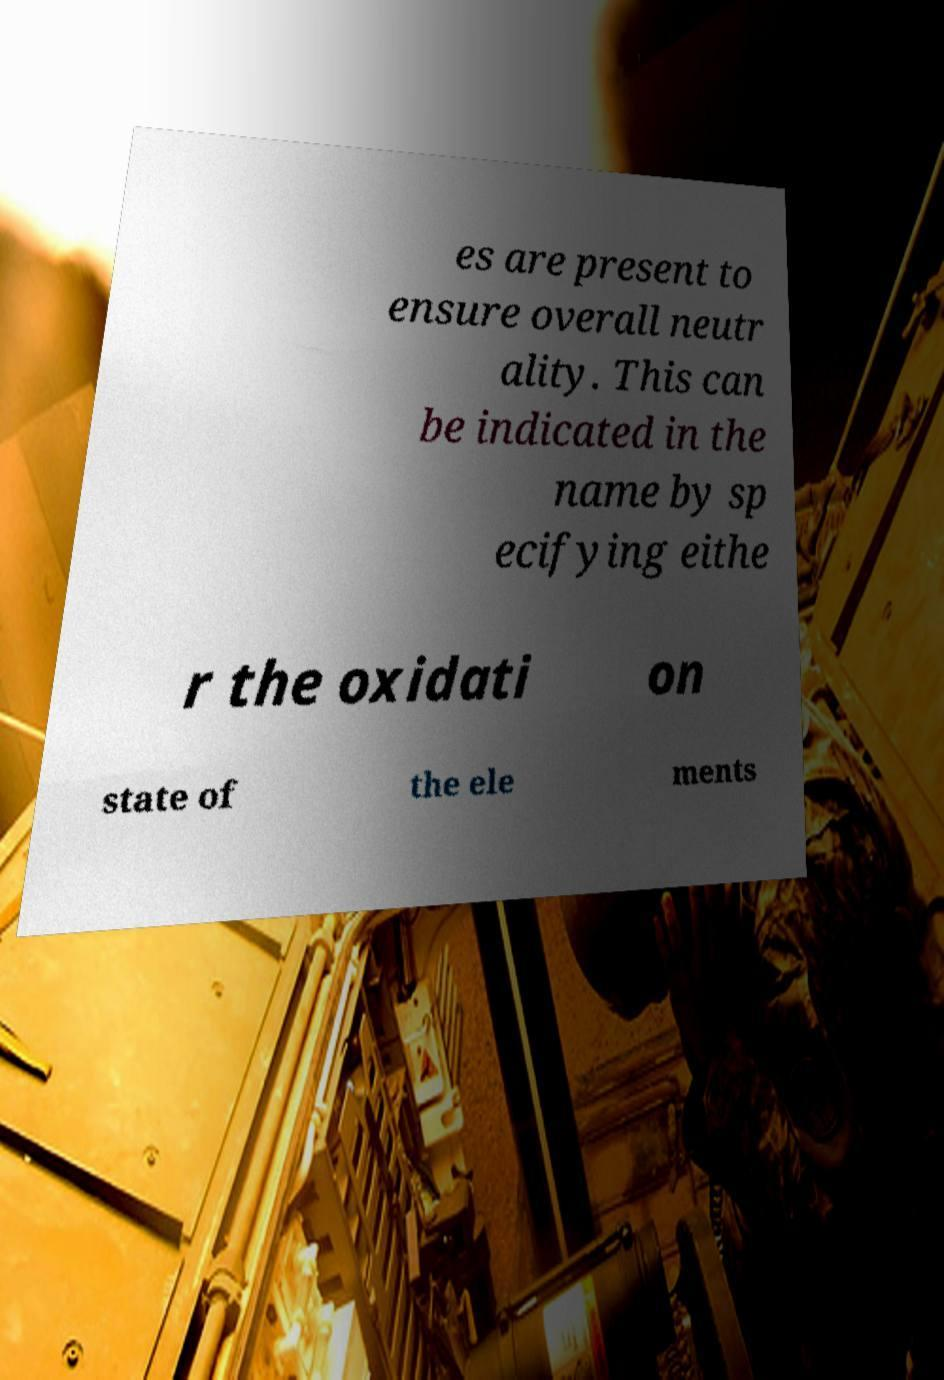Please identify and transcribe the text found in this image. es are present to ensure overall neutr ality. This can be indicated in the name by sp ecifying eithe r the oxidati on state of the ele ments 